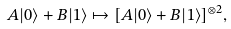<formula> <loc_0><loc_0><loc_500><loc_500>A | 0 \rangle + B | 1 \rangle \mapsto [ A | 0 \rangle + B | 1 \rangle ] ^ { \otimes 2 } ,</formula> 